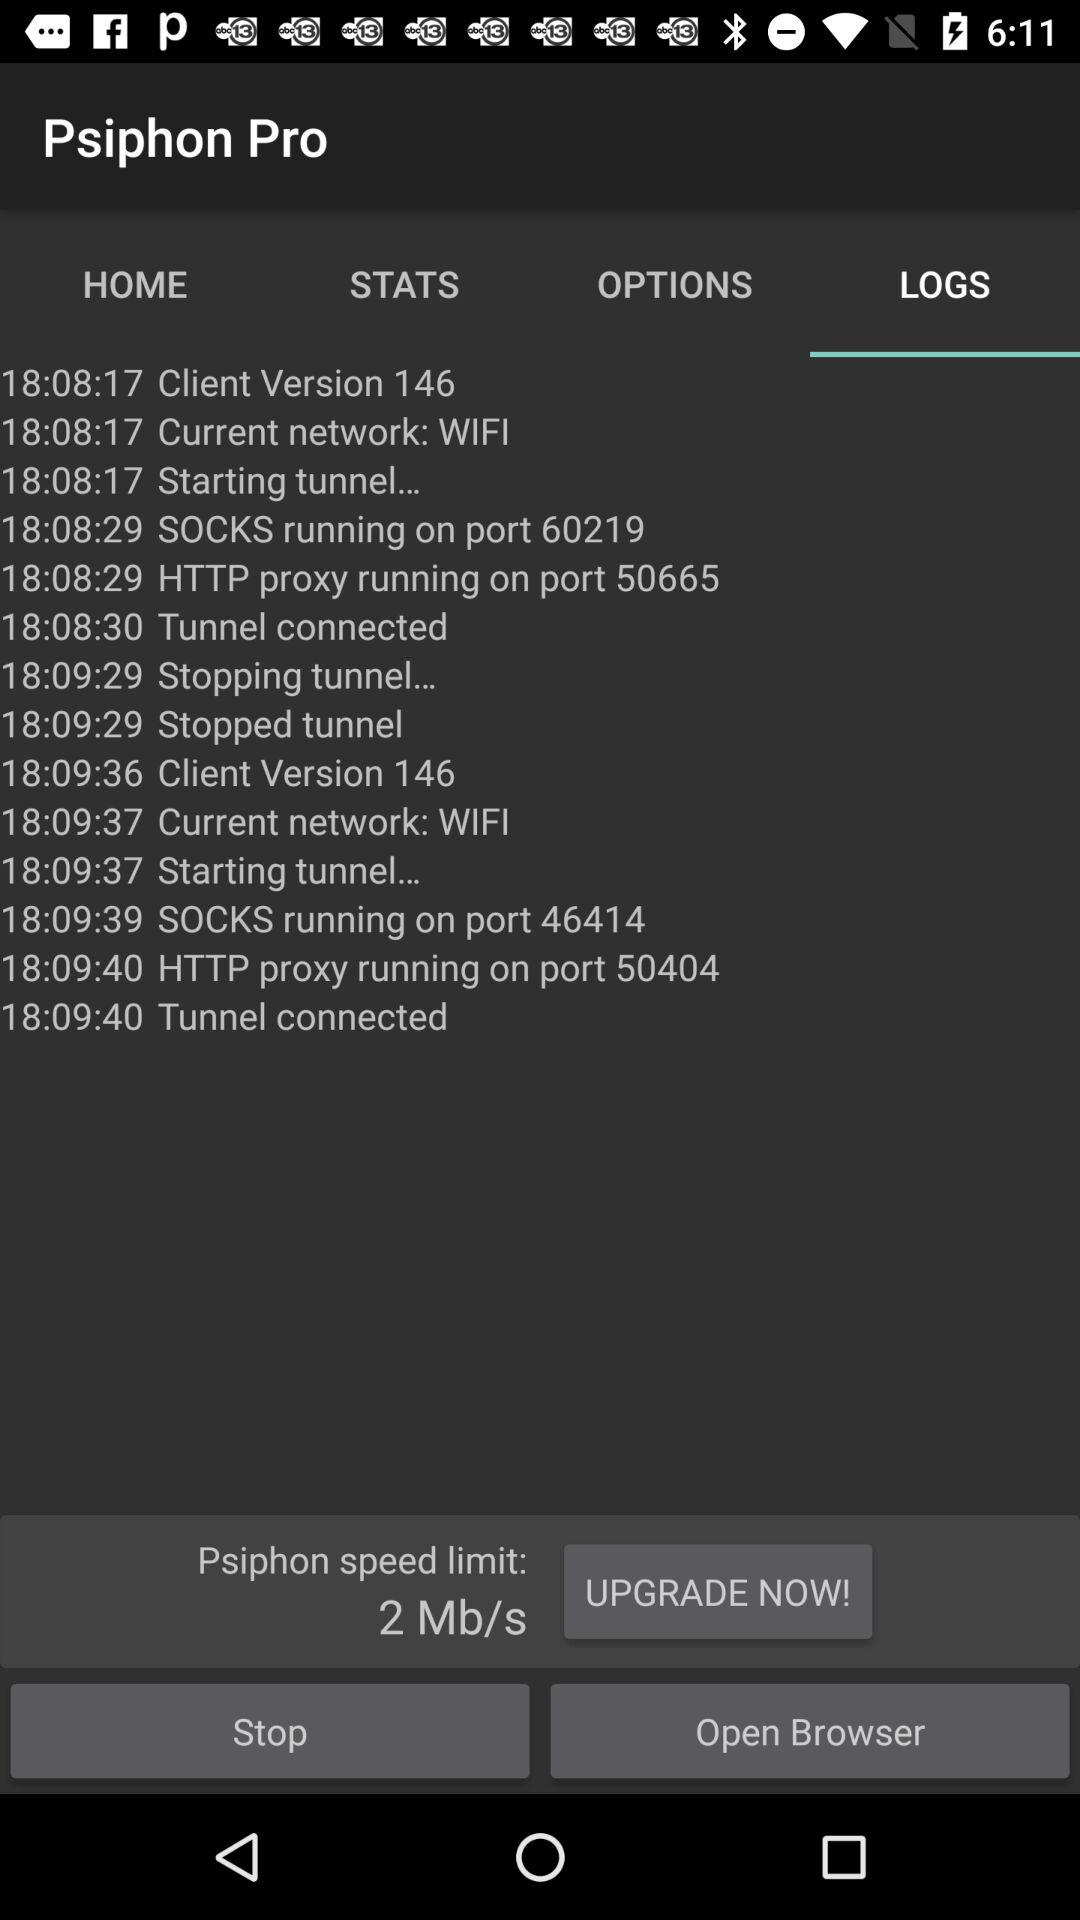What is the client version for 18:08:17? The client version is 146. 